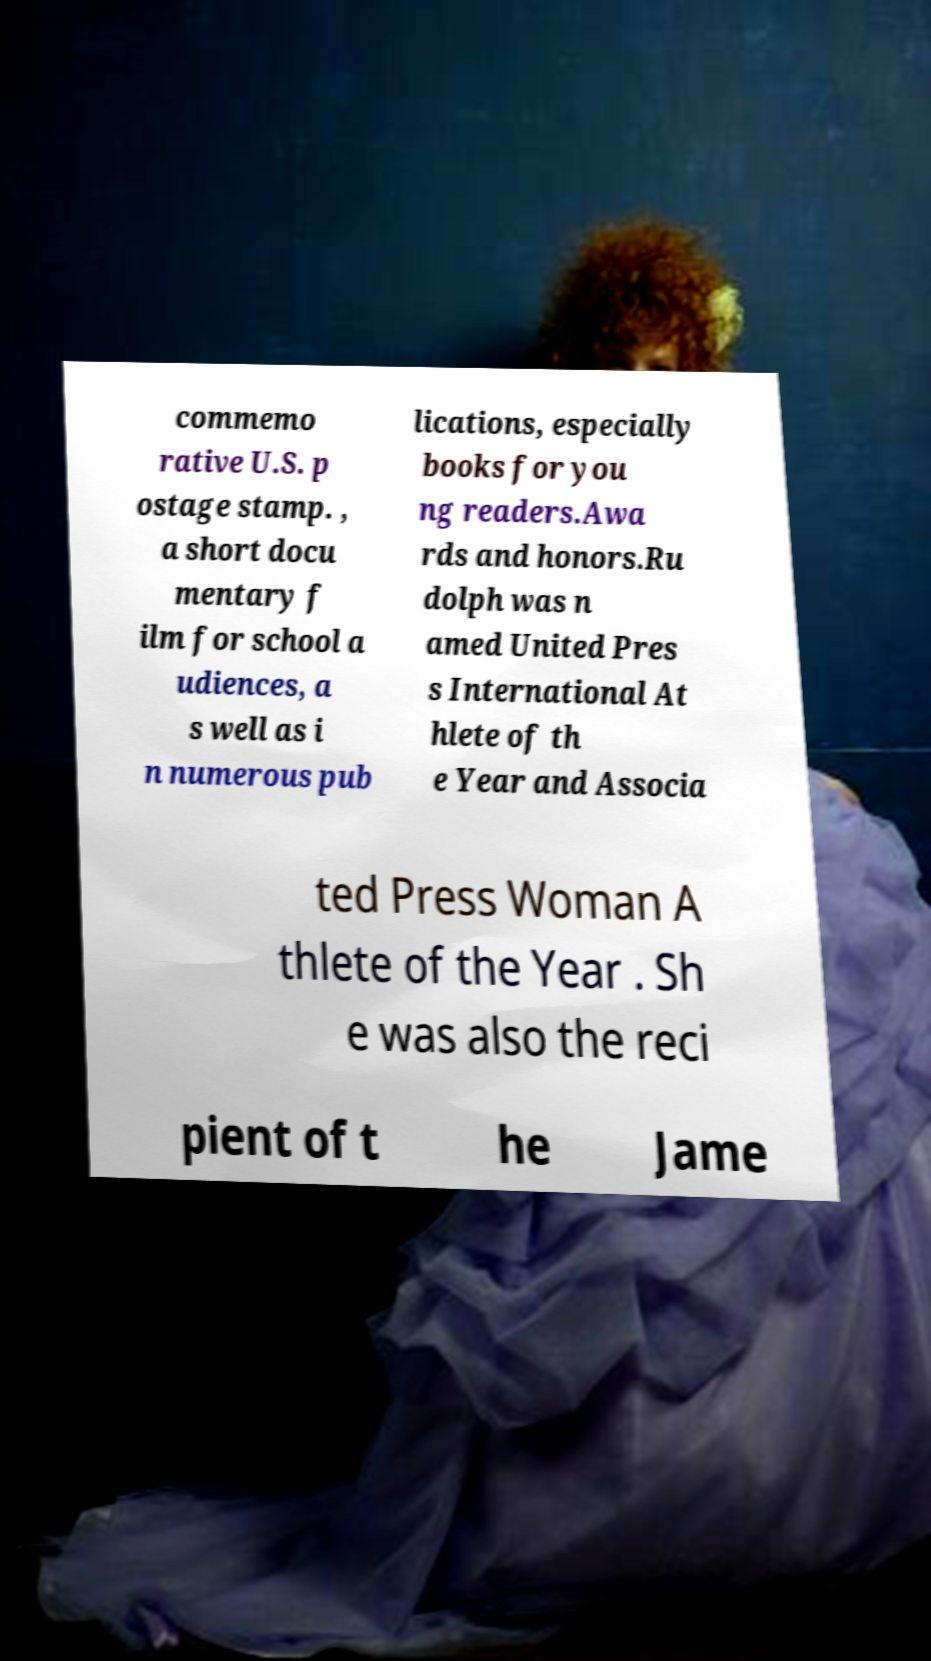For documentation purposes, I need the text within this image transcribed. Could you provide that? commemo rative U.S. p ostage stamp. , a short docu mentary f ilm for school a udiences, a s well as i n numerous pub lications, especially books for you ng readers.Awa rds and honors.Ru dolph was n amed United Pres s International At hlete of th e Year and Associa ted Press Woman A thlete of the Year . Sh e was also the reci pient of t he Jame 